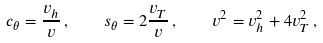Convert formula to latex. <formula><loc_0><loc_0><loc_500><loc_500>c _ { \theta } = \frac { v _ { h } } { v } \, , \quad s _ { \theta } = 2 \frac { v _ { T } } { v } \, , \quad v ^ { 2 } = v _ { h } ^ { 2 } + 4 v _ { T } ^ { 2 } \, ,</formula> 